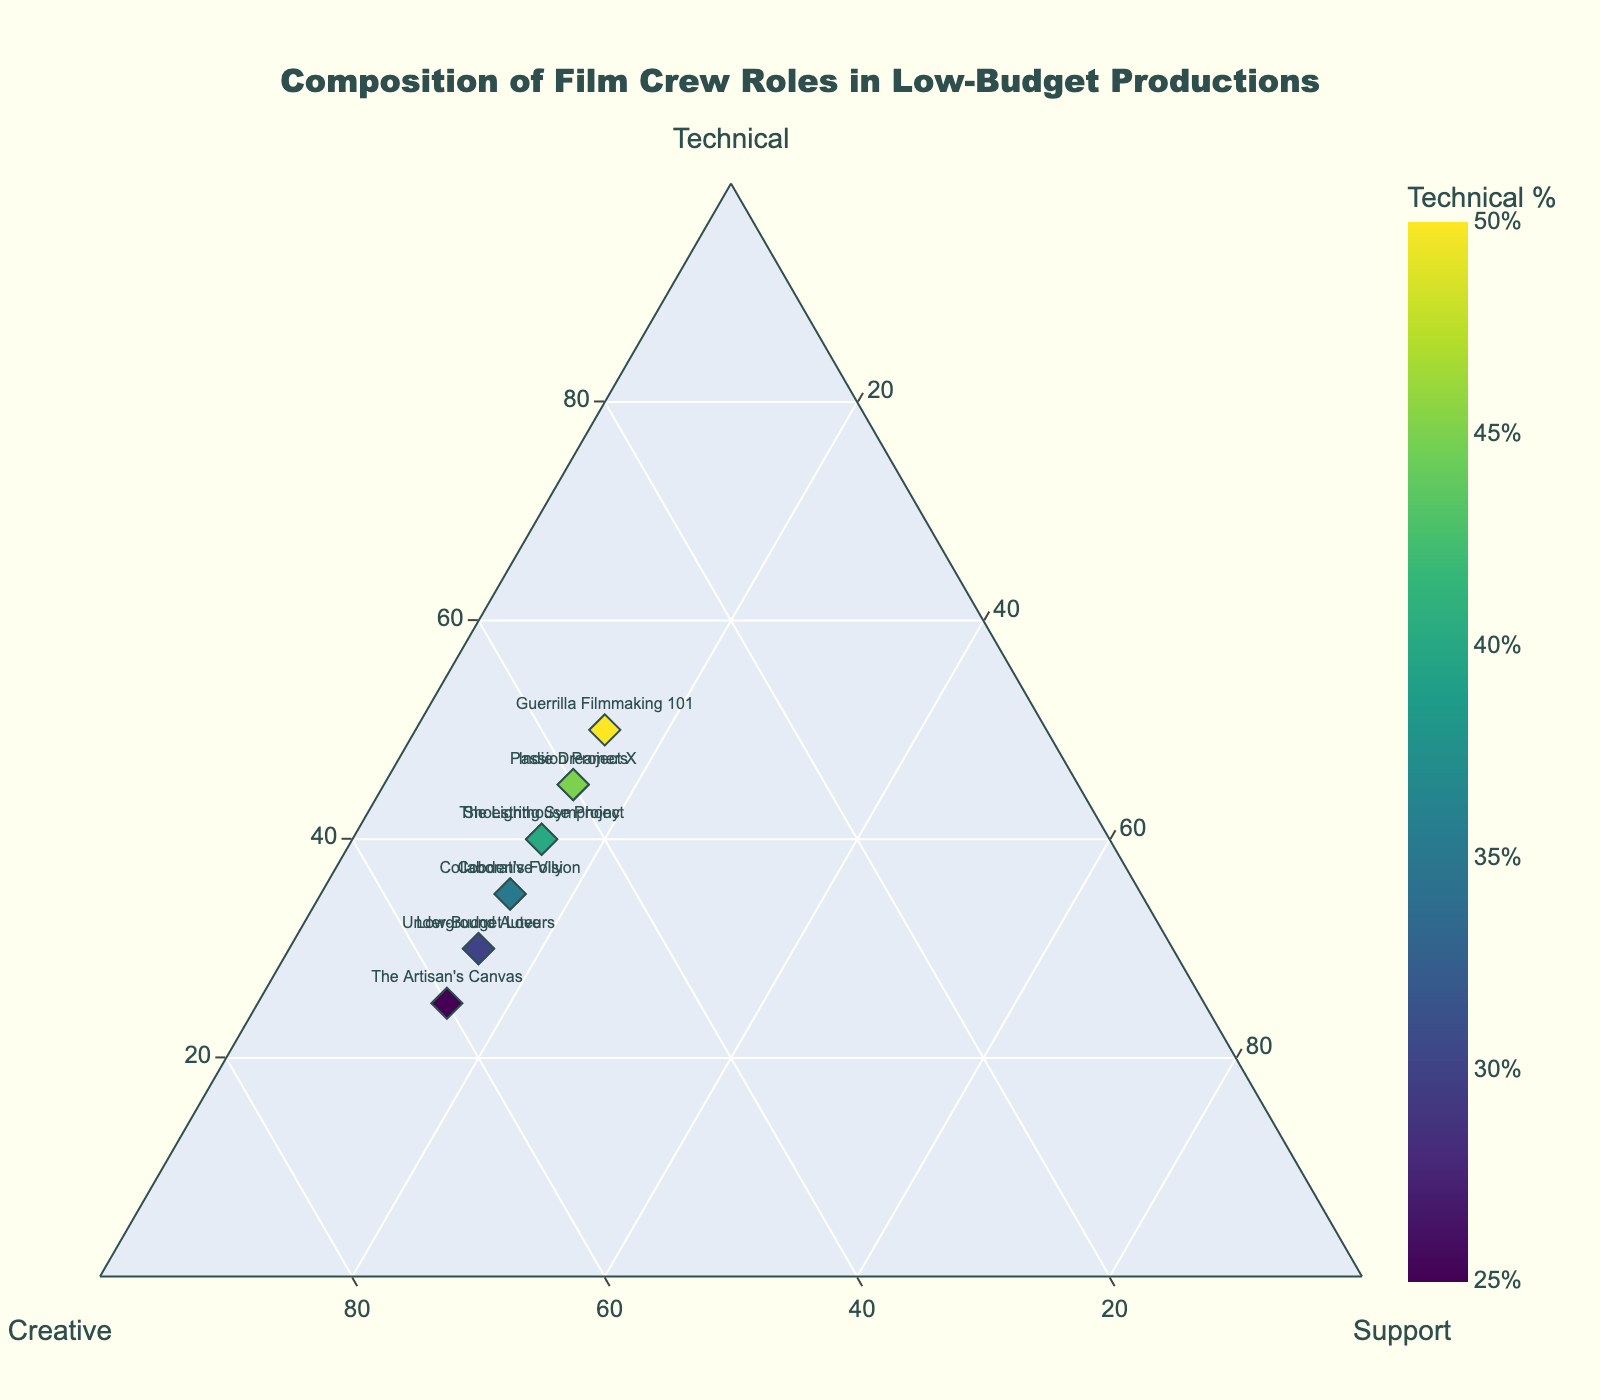What is the title of the plot? The title of the plot is located at the top of the figure. It's in a larger font size and usually stands out due to its prominence.
Answer: Composition of Film Crew Roles in Low-Budget Productions How many films have exactly 15% of support staff? By counting the markers labeled with film names where the 'Support' axis reads 15%, we can identify the total number. There are 10 films listed, and all have 15% support staff.
Answer: 10 Which film has the lowest percentage of Technical staff? Identify the film that appears closest to the corner labeled 'Creative' and far from the 'Technical' corner. "The Artisan's Canvas" is the film positioned with the lowest value on the 'Technical' axis.
Answer: The Artisan's Canvas What is the sum of percentages for Technical and Creative staff in "Passion Project X"? Add the percentage of Technical staff (45) and Creative staff (40) from the point labeled "Passion Project X".
Answer: 85 Which film has the highest percentage of Creative staff? Find the film plotted closest to the corner associated with 'Creative'. "The Artisan's Canvas" is located at the highest point on the 'Creative' axis with 60%.
Answer: The Artisan's Canvas Which two films have an equal composition of Technical, Creative, and Support staff? Look for films occupying the same position on the ternary plot. "Cobden's Folly" and "Collaborative Vision" share an identical composition (35% Technical, 50% Creative, 15% Support).
Answer: Cobden's Folly, Collaborative Vision How does the composition of the crew in "Guerrilla Filmmaking 101" compare to "The Lighthouse Project"? Compare the positions of these two films on the ternary plot. "Guerrilla Filmmaking 101" has more Technical staff (50% vs. 40%), less Creative staff (35% vs. 45%), and the same Support staff (15%).
Answer: More Technical, less Creative, same Support What's the difference in percentage of Technical staff between "Indie Dreamers" and "Low-Budget Love"? Subtract the percentage of Technical staff in "Low-Budget Love" (30) from "Indie Dreamers" (45).
Answer: 15 What is the average percentage of Creative staff across all films listed? Sum up the Creative percentages (45, 50, 40, 55, 35, 60, 45, 50, 55, 40) and divide by the number of films (10). The computation is: (45+50+40+55+35+60+45+50+55+40)/10 = 47.5
Answer: 47.5 